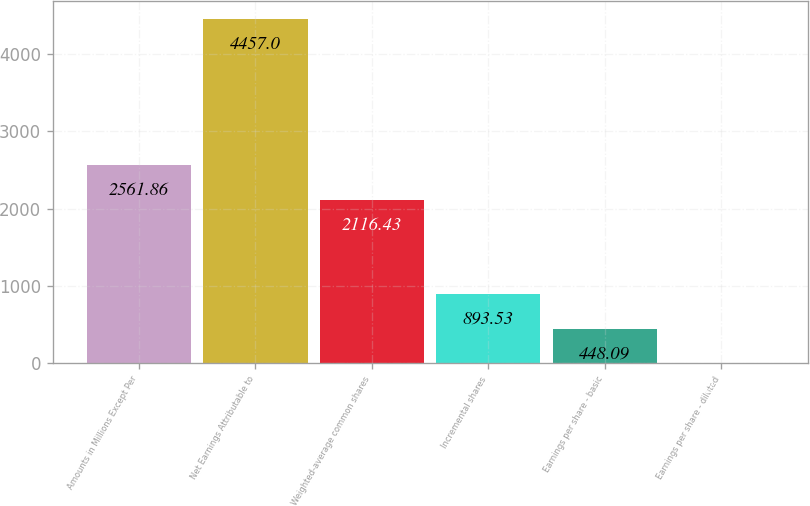<chart> <loc_0><loc_0><loc_500><loc_500><bar_chart><fcel>Amounts in Millions Except Per<fcel>Net Earnings Attributable to<fcel>Weighted-average common shares<fcel>Incremental shares<fcel>Earnings per share - basic<fcel>Earnings per share - diluted<nl><fcel>2561.86<fcel>4457<fcel>2116.43<fcel>893.53<fcel>448.09<fcel>2.65<nl></chart> 